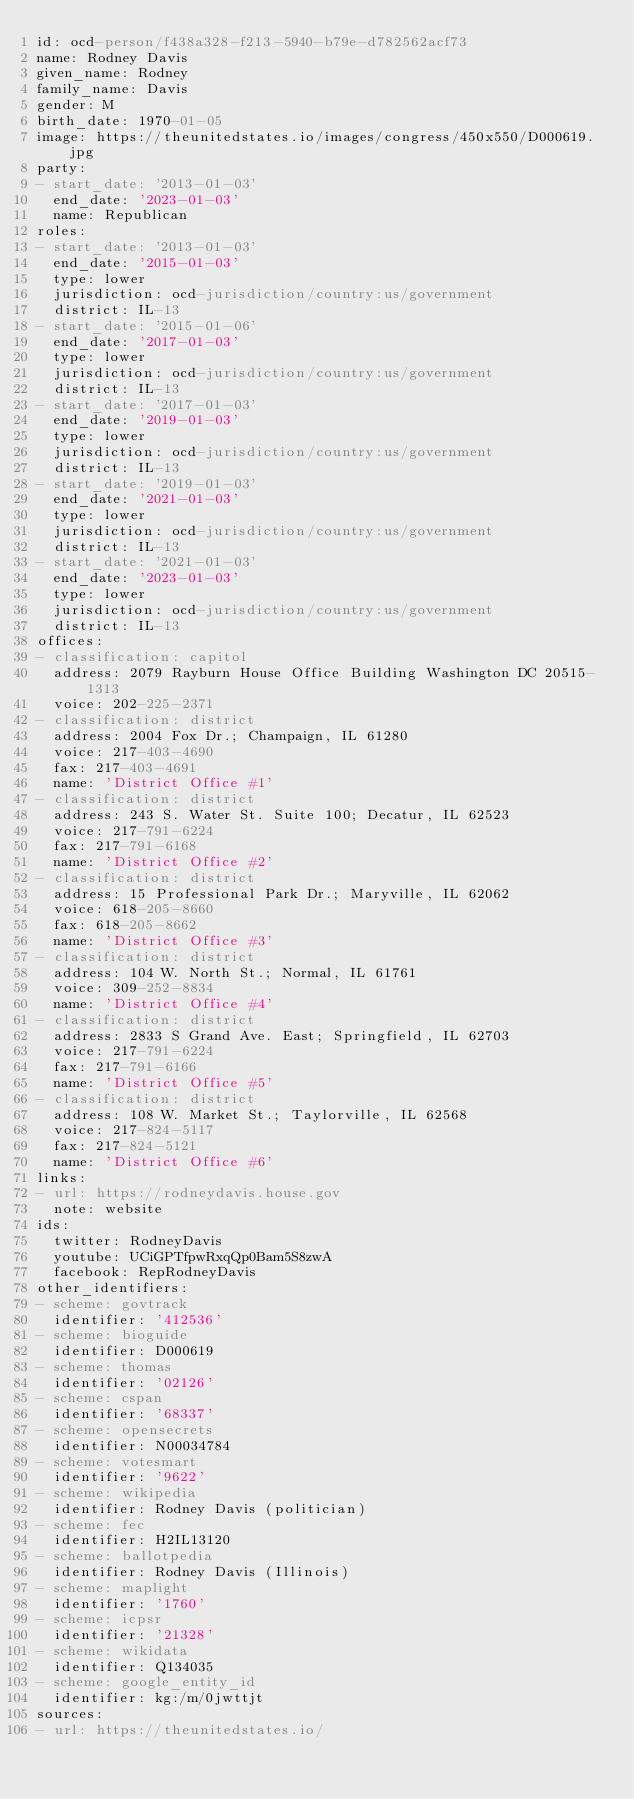Convert code to text. <code><loc_0><loc_0><loc_500><loc_500><_YAML_>id: ocd-person/f438a328-f213-5940-b79e-d782562acf73
name: Rodney Davis
given_name: Rodney
family_name: Davis
gender: M
birth_date: 1970-01-05
image: https://theunitedstates.io/images/congress/450x550/D000619.jpg
party:
- start_date: '2013-01-03'
  end_date: '2023-01-03'
  name: Republican
roles:
- start_date: '2013-01-03'
  end_date: '2015-01-03'
  type: lower
  jurisdiction: ocd-jurisdiction/country:us/government
  district: IL-13
- start_date: '2015-01-06'
  end_date: '2017-01-03'
  type: lower
  jurisdiction: ocd-jurisdiction/country:us/government
  district: IL-13
- start_date: '2017-01-03'
  end_date: '2019-01-03'
  type: lower
  jurisdiction: ocd-jurisdiction/country:us/government
  district: IL-13
- start_date: '2019-01-03'
  end_date: '2021-01-03'
  type: lower
  jurisdiction: ocd-jurisdiction/country:us/government
  district: IL-13
- start_date: '2021-01-03'
  end_date: '2023-01-03'
  type: lower
  jurisdiction: ocd-jurisdiction/country:us/government
  district: IL-13
offices:
- classification: capitol
  address: 2079 Rayburn House Office Building Washington DC 20515-1313
  voice: 202-225-2371
- classification: district
  address: 2004 Fox Dr.; Champaign, IL 61280
  voice: 217-403-4690
  fax: 217-403-4691
  name: 'District Office #1'
- classification: district
  address: 243 S. Water St. Suite 100; Decatur, IL 62523
  voice: 217-791-6224
  fax: 217-791-6168
  name: 'District Office #2'
- classification: district
  address: 15 Professional Park Dr.; Maryville, IL 62062
  voice: 618-205-8660
  fax: 618-205-8662
  name: 'District Office #3'
- classification: district
  address: 104 W. North St.; Normal, IL 61761
  voice: 309-252-8834
  name: 'District Office #4'
- classification: district
  address: 2833 S Grand Ave. East; Springfield, IL 62703
  voice: 217-791-6224
  fax: 217-791-6166
  name: 'District Office #5'
- classification: district
  address: 108 W. Market St.; Taylorville, IL 62568
  voice: 217-824-5117
  fax: 217-824-5121
  name: 'District Office #6'
links:
- url: https://rodneydavis.house.gov
  note: website
ids:
  twitter: RodneyDavis
  youtube: UCiGPTfpwRxqQp0Bam5S8zwA
  facebook: RepRodneyDavis
other_identifiers:
- scheme: govtrack
  identifier: '412536'
- scheme: bioguide
  identifier: D000619
- scheme: thomas
  identifier: '02126'
- scheme: cspan
  identifier: '68337'
- scheme: opensecrets
  identifier: N00034784
- scheme: votesmart
  identifier: '9622'
- scheme: wikipedia
  identifier: Rodney Davis (politician)
- scheme: fec
  identifier: H2IL13120
- scheme: ballotpedia
  identifier: Rodney Davis (Illinois)
- scheme: maplight
  identifier: '1760'
- scheme: icpsr
  identifier: '21328'
- scheme: wikidata
  identifier: Q134035
- scheme: google_entity_id
  identifier: kg:/m/0jwttjt
sources:
- url: https://theunitedstates.io/
</code> 